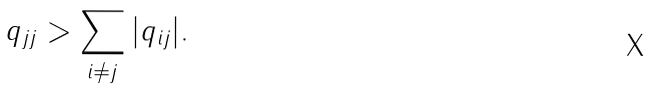Convert formula to latex. <formula><loc_0><loc_0><loc_500><loc_500>q _ { j j } > \sum _ { i \neq j } | q _ { i j } | .</formula> 